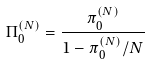<formula> <loc_0><loc_0><loc_500><loc_500>\Pi _ { 0 } ^ { ( N ) } = \frac { \pi _ { 0 } ^ { ( N ) } } { 1 - \pi _ { 0 } ^ { ( N ) } / N }</formula> 